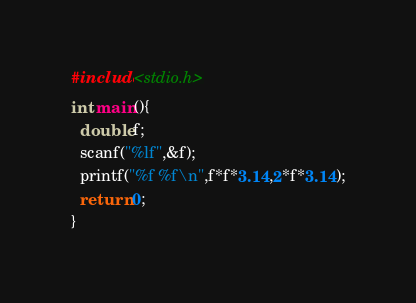Convert code to text. <code><loc_0><loc_0><loc_500><loc_500><_C_>#include<stdio.h>
int main(){
  double f;
  scanf("%lf",&f);
  printf("%f %f\n",f*f*3.14,2*f*3.14);
  return 0;
}
</code> 